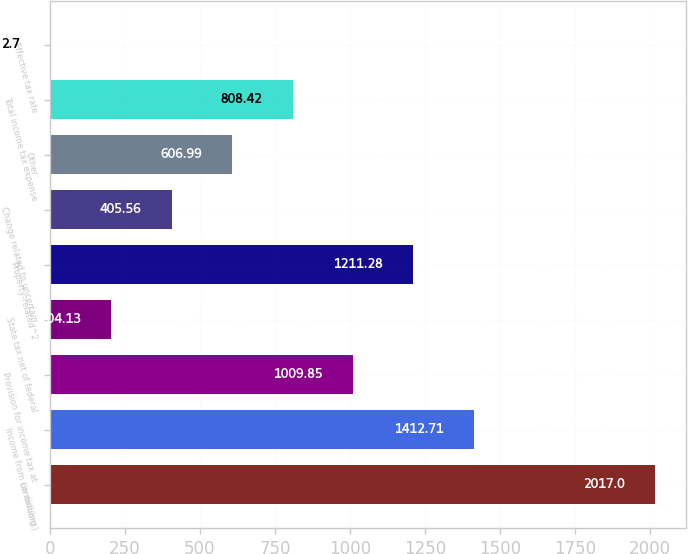Convert chart. <chart><loc_0><loc_0><loc_500><loc_500><bar_chart><fcel>(in millions)<fcel>Income from continuing<fcel>Provision for income tax at<fcel>State tax net of federal<fcel>Property-related^2<fcel>Change related to uncertain<fcel>Other<fcel>Total income tax expense<fcel>Effective tax rate<nl><fcel>2017<fcel>1412.71<fcel>1009.85<fcel>204.13<fcel>1211.28<fcel>405.56<fcel>606.99<fcel>808.42<fcel>2.7<nl></chart> 